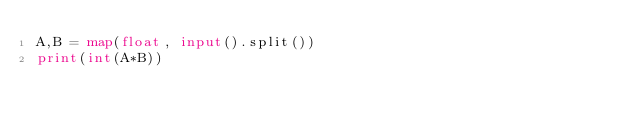Convert code to text. <code><loc_0><loc_0><loc_500><loc_500><_Python_>A,B = map(float, input().split())
print(int(A*B))
</code> 